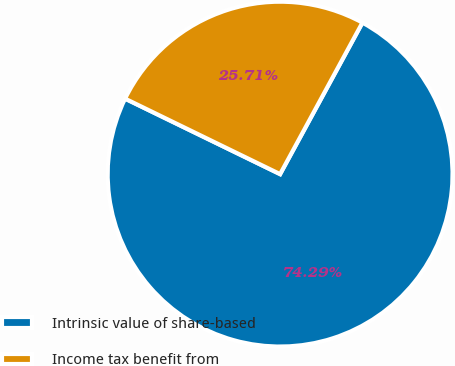Convert chart. <chart><loc_0><loc_0><loc_500><loc_500><pie_chart><fcel>Intrinsic value of share-based<fcel>Income tax benefit from<nl><fcel>74.29%<fcel>25.71%<nl></chart> 